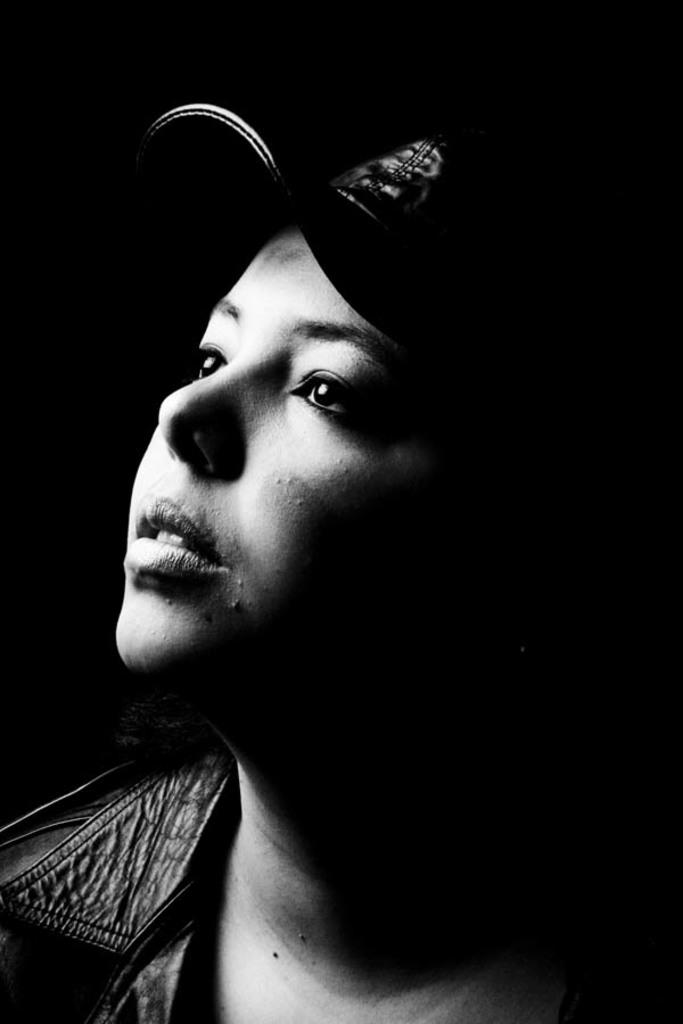What is the main subject of the image? The main subject of the image is a woman's face. What is the woman wearing on her head? The woman is wearing a cap. What color scheme is used in the image? The image is in black and white color. How many babies are visible in the image? There are no babies present in the image; it features a woman's face wearing a cap. What type of monkey can be seen interacting with the woman in the image? There is no monkey present in the image; it only features a woman's face wearing a cap. 